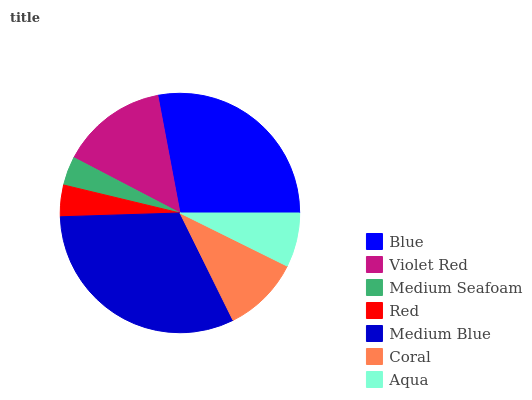Is Medium Seafoam the minimum?
Answer yes or no. Yes. Is Medium Blue the maximum?
Answer yes or no. Yes. Is Violet Red the minimum?
Answer yes or no. No. Is Violet Red the maximum?
Answer yes or no. No. Is Blue greater than Violet Red?
Answer yes or no. Yes. Is Violet Red less than Blue?
Answer yes or no. Yes. Is Violet Red greater than Blue?
Answer yes or no. No. Is Blue less than Violet Red?
Answer yes or no. No. Is Coral the high median?
Answer yes or no. Yes. Is Coral the low median?
Answer yes or no. Yes. Is Aqua the high median?
Answer yes or no. No. Is Medium Seafoam the low median?
Answer yes or no. No. 